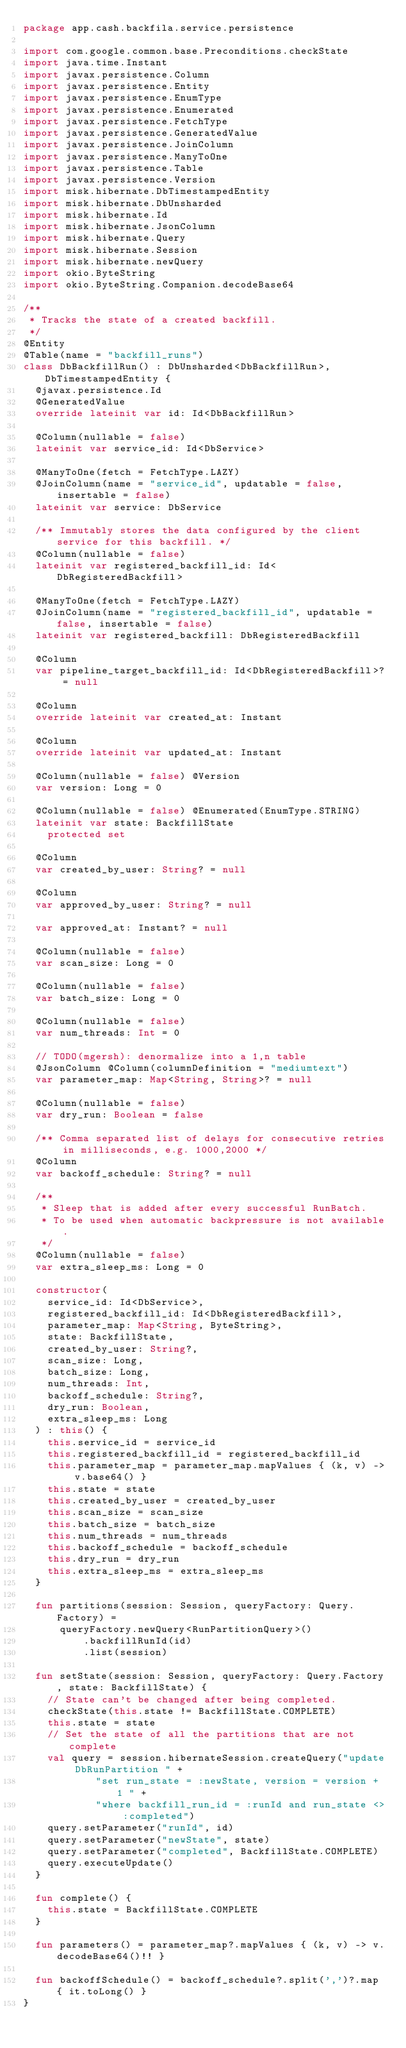<code> <loc_0><loc_0><loc_500><loc_500><_Kotlin_>package app.cash.backfila.service.persistence

import com.google.common.base.Preconditions.checkState
import java.time.Instant
import javax.persistence.Column
import javax.persistence.Entity
import javax.persistence.EnumType
import javax.persistence.Enumerated
import javax.persistence.FetchType
import javax.persistence.GeneratedValue
import javax.persistence.JoinColumn
import javax.persistence.ManyToOne
import javax.persistence.Table
import javax.persistence.Version
import misk.hibernate.DbTimestampedEntity
import misk.hibernate.DbUnsharded
import misk.hibernate.Id
import misk.hibernate.JsonColumn
import misk.hibernate.Query
import misk.hibernate.Session
import misk.hibernate.newQuery
import okio.ByteString
import okio.ByteString.Companion.decodeBase64

/**
 * Tracks the state of a created backfill.
 */
@Entity
@Table(name = "backfill_runs")
class DbBackfillRun() : DbUnsharded<DbBackfillRun>, DbTimestampedEntity {
  @javax.persistence.Id
  @GeneratedValue
  override lateinit var id: Id<DbBackfillRun>

  @Column(nullable = false)
  lateinit var service_id: Id<DbService>

  @ManyToOne(fetch = FetchType.LAZY)
  @JoinColumn(name = "service_id", updatable = false, insertable = false)
  lateinit var service: DbService

  /** Immutably stores the data configured by the client service for this backfill. */
  @Column(nullable = false)
  lateinit var registered_backfill_id: Id<DbRegisteredBackfill>

  @ManyToOne(fetch = FetchType.LAZY)
  @JoinColumn(name = "registered_backfill_id", updatable = false, insertable = false)
  lateinit var registered_backfill: DbRegisteredBackfill

  @Column
  var pipeline_target_backfill_id: Id<DbRegisteredBackfill>? = null

  @Column
  override lateinit var created_at: Instant

  @Column
  override lateinit var updated_at: Instant

  @Column(nullable = false) @Version
  var version: Long = 0

  @Column(nullable = false) @Enumerated(EnumType.STRING)
  lateinit var state: BackfillState
    protected set

  @Column
  var created_by_user: String? = null

  @Column
  var approved_by_user: String? = null

  var approved_at: Instant? = null

  @Column(nullable = false)
  var scan_size: Long = 0

  @Column(nullable = false)
  var batch_size: Long = 0

  @Column(nullable = false)
  var num_threads: Int = 0

  // TODO(mgersh): denormalize into a 1,n table
  @JsonColumn @Column(columnDefinition = "mediumtext")
  var parameter_map: Map<String, String>? = null

  @Column(nullable = false)
  var dry_run: Boolean = false

  /** Comma separated list of delays for consecutive retries in milliseconds, e.g. 1000,2000 */
  @Column
  var backoff_schedule: String? = null

  /**
   * Sleep that is added after every successful RunBatch.
   * To be used when automatic backpressure is not available.
   */
  @Column(nullable = false)
  var extra_sleep_ms: Long = 0

  constructor(
    service_id: Id<DbService>,
    registered_backfill_id: Id<DbRegisteredBackfill>,
    parameter_map: Map<String, ByteString>,
    state: BackfillState,
    created_by_user: String?,
    scan_size: Long,
    batch_size: Long,
    num_threads: Int,
    backoff_schedule: String?,
    dry_run: Boolean,
    extra_sleep_ms: Long
  ) : this() {
    this.service_id = service_id
    this.registered_backfill_id = registered_backfill_id
    this.parameter_map = parameter_map.mapValues { (k, v) -> v.base64() }
    this.state = state
    this.created_by_user = created_by_user
    this.scan_size = scan_size
    this.batch_size = batch_size
    this.num_threads = num_threads
    this.backoff_schedule = backoff_schedule
    this.dry_run = dry_run
    this.extra_sleep_ms = extra_sleep_ms
  }

  fun partitions(session: Session, queryFactory: Query.Factory) =
      queryFactory.newQuery<RunPartitionQuery>()
          .backfillRunId(id)
          .list(session)

  fun setState(session: Session, queryFactory: Query.Factory, state: BackfillState) {
    // State can't be changed after being completed.
    checkState(this.state != BackfillState.COMPLETE)
    this.state = state
    // Set the state of all the partitions that are not complete
    val query = session.hibernateSession.createQuery("update DbRunPartition " +
            "set run_state = :newState, version = version + 1 " +
            "where backfill_run_id = :runId and run_state <> :completed")
    query.setParameter("runId", id)
    query.setParameter("newState", state)
    query.setParameter("completed", BackfillState.COMPLETE)
    query.executeUpdate()
  }

  fun complete() {
    this.state = BackfillState.COMPLETE
  }

  fun parameters() = parameter_map?.mapValues { (k, v) -> v.decodeBase64()!! }

  fun backoffSchedule() = backoff_schedule?.split(',')?.map { it.toLong() }
}
</code> 